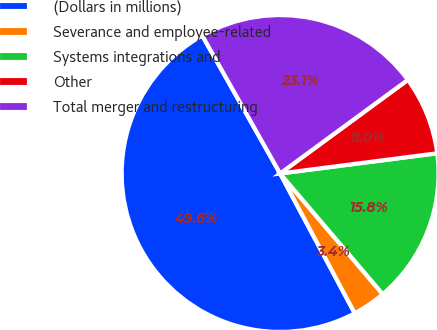Convert chart. <chart><loc_0><loc_0><loc_500><loc_500><pie_chart><fcel>(Dollars in millions)<fcel>Severance and employee-related<fcel>Systems integrations and<fcel>Other<fcel>Total merger and restructuring<nl><fcel>49.63%<fcel>3.41%<fcel>15.82%<fcel>8.03%<fcel>23.11%<nl></chart> 